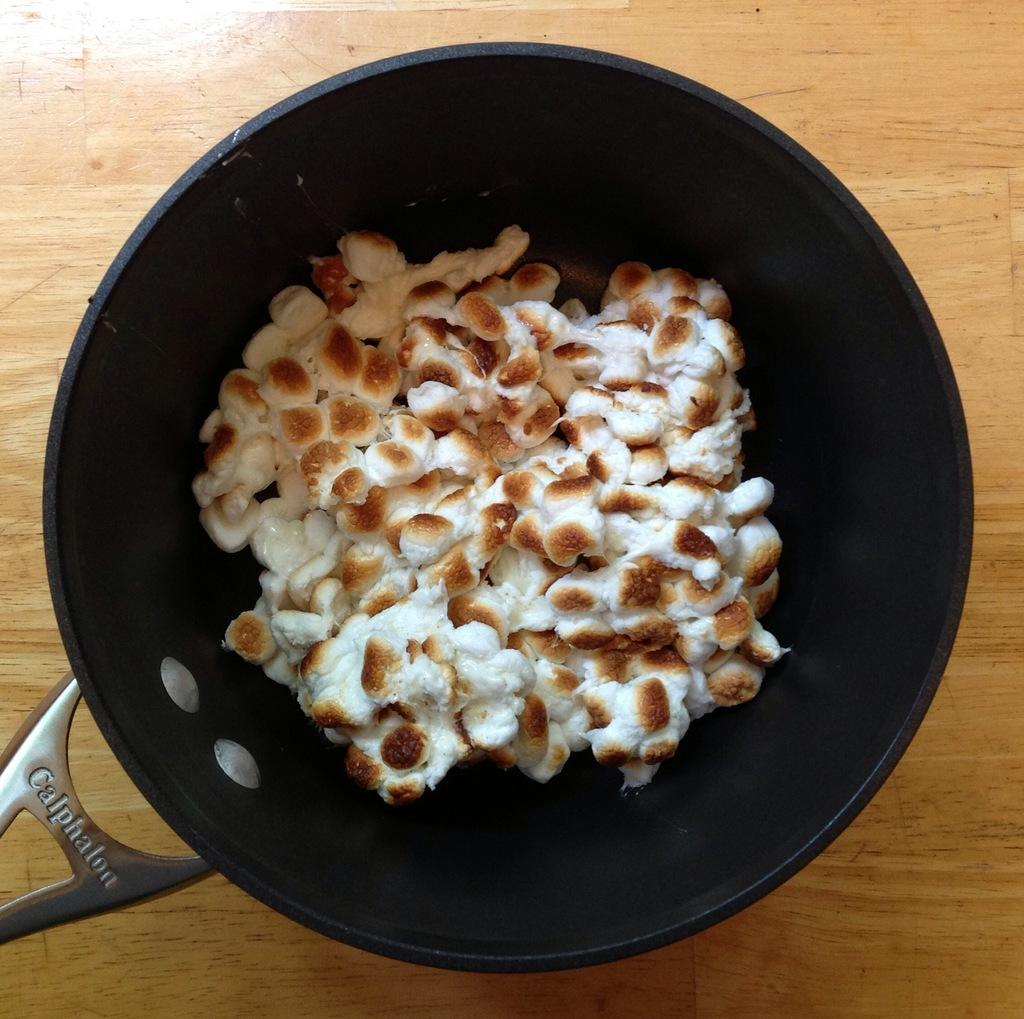What is the main object in the image? There is a pan in the image. What is inside the pan? The pan contains a food item. What type of surface is the pan placed on? The wooden surface is present in the image. How many pets are visible in the image? There are no pets present in the image. What type of plot is being developed in the image? There is no plot development in the image; it features a pan with a food item on a wooden surface. 